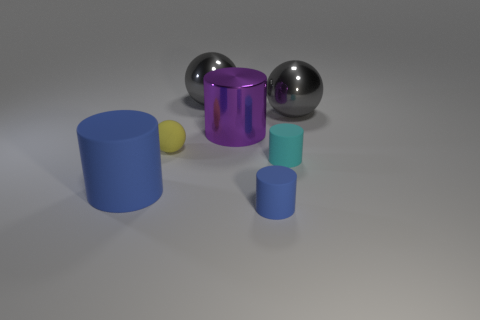There is a tiny cyan matte thing; are there any small blue rubber things to the right of it?
Give a very brief answer. No. What is the size of the yellow object that is made of the same material as the cyan object?
Your response must be concise. Small. How many big blue things have the same shape as the small cyan object?
Make the answer very short. 1. Does the big blue cylinder have the same material as the big gray ball right of the small blue object?
Keep it short and to the point. No. Is the number of large blue matte cylinders right of the big shiny cylinder greater than the number of big things?
Your answer should be compact. No. The tiny thing that is the same color as the large rubber cylinder is what shape?
Provide a succinct answer. Cylinder. Are there any green cylinders that have the same material as the cyan thing?
Keep it short and to the point. No. Does the large thing that is on the right side of the purple thing have the same material as the small thing behind the small cyan matte cylinder?
Offer a terse response. No. Is the number of large objects that are on the left side of the big purple thing the same as the number of small matte objects to the right of the yellow ball?
Your answer should be very brief. Yes. There is another rubber cylinder that is the same size as the purple cylinder; what color is it?
Make the answer very short. Blue. 